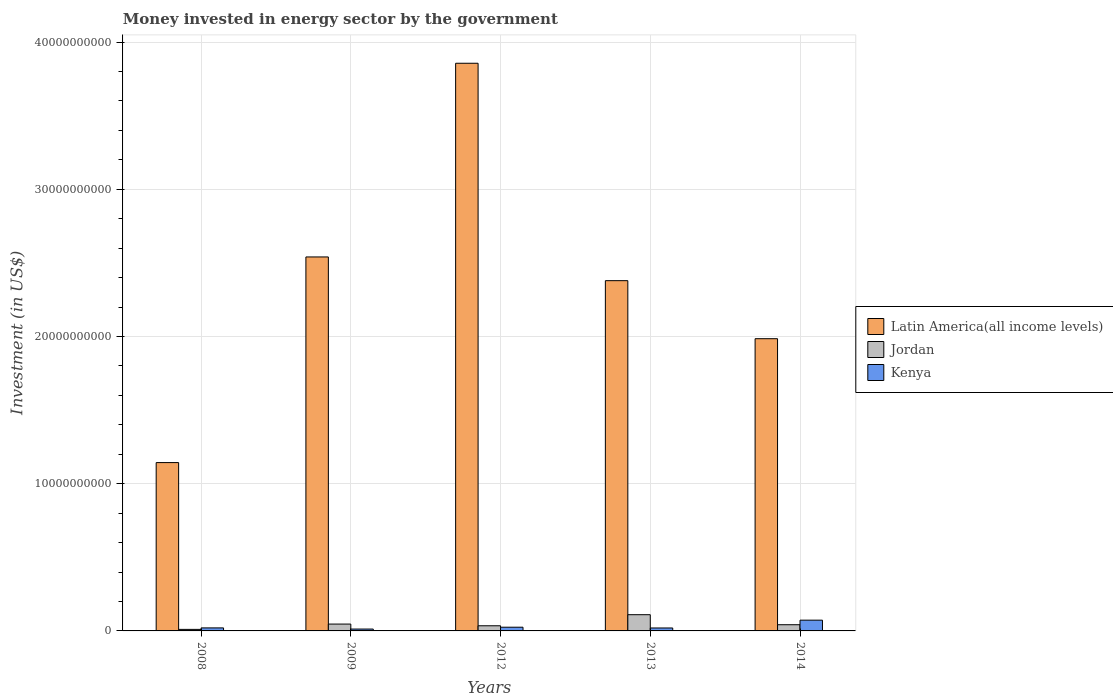Are the number of bars per tick equal to the number of legend labels?
Give a very brief answer. Yes. How many bars are there on the 2nd tick from the left?
Give a very brief answer. 3. In how many cases, is the number of bars for a given year not equal to the number of legend labels?
Provide a succinct answer. 0. What is the money spent in energy sector in Kenya in 2009?
Your answer should be very brief. 1.27e+08. Across all years, what is the maximum money spent in energy sector in Kenya?
Ensure brevity in your answer.  7.30e+08. Across all years, what is the minimum money spent in energy sector in Kenya?
Your response must be concise. 1.27e+08. In which year was the money spent in energy sector in Latin America(all income levels) minimum?
Your answer should be compact. 2008. What is the total money spent in energy sector in Jordan in the graph?
Ensure brevity in your answer.  2.44e+09. What is the difference between the money spent in energy sector in Kenya in 2009 and that in 2014?
Give a very brief answer. -6.04e+08. What is the difference between the money spent in energy sector in Kenya in 2008 and the money spent in energy sector in Jordan in 2009?
Your answer should be very brief. -2.60e+08. What is the average money spent in energy sector in Jordan per year?
Ensure brevity in your answer.  4.88e+08. In the year 2009, what is the difference between the money spent in energy sector in Latin America(all income levels) and money spent in energy sector in Jordan?
Offer a terse response. 2.49e+1. What is the ratio of the money spent in energy sector in Jordan in 2012 to that in 2014?
Give a very brief answer. 0.83. Is the difference between the money spent in energy sector in Latin America(all income levels) in 2012 and 2014 greater than the difference between the money spent in energy sector in Jordan in 2012 and 2014?
Your answer should be compact. Yes. What is the difference between the highest and the second highest money spent in energy sector in Latin America(all income levels)?
Provide a short and direct response. 1.32e+1. What is the difference between the highest and the lowest money spent in energy sector in Latin America(all income levels)?
Provide a short and direct response. 2.71e+1. Is the sum of the money spent in energy sector in Kenya in 2009 and 2012 greater than the maximum money spent in energy sector in Latin America(all income levels) across all years?
Ensure brevity in your answer.  No. What does the 2nd bar from the left in 2013 represents?
Your answer should be very brief. Jordan. What does the 3rd bar from the right in 2009 represents?
Make the answer very short. Latin America(all income levels). Are all the bars in the graph horizontal?
Give a very brief answer. No. How many years are there in the graph?
Ensure brevity in your answer.  5. What is the title of the graph?
Ensure brevity in your answer.  Money invested in energy sector by the government. What is the label or title of the X-axis?
Give a very brief answer. Years. What is the label or title of the Y-axis?
Your answer should be compact. Investment (in US$). What is the Investment (in US$) in Latin America(all income levels) in 2008?
Your answer should be very brief. 1.14e+1. What is the Investment (in US$) of Jordan in 2008?
Your response must be concise. 1.04e+08. What is the Investment (in US$) of Kenya in 2008?
Make the answer very short. 2.05e+08. What is the Investment (in US$) in Latin America(all income levels) in 2009?
Make the answer very short. 2.54e+1. What is the Investment (in US$) in Jordan in 2009?
Ensure brevity in your answer.  4.65e+08. What is the Investment (in US$) in Kenya in 2009?
Make the answer very short. 1.27e+08. What is the Investment (in US$) of Latin America(all income levels) in 2012?
Your answer should be very brief. 3.86e+1. What is the Investment (in US$) in Jordan in 2012?
Make the answer very short. 3.50e+08. What is the Investment (in US$) in Kenya in 2012?
Ensure brevity in your answer.  2.52e+08. What is the Investment (in US$) in Latin America(all income levels) in 2013?
Your response must be concise. 2.38e+1. What is the Investment (in US$) in Jordan in 2013?
Keep it short and to the point. 1.10e+09. What is the Investment (in US$) of Latin America(all income levels) in 2014?
Give a very brief answer. 1.98e+1. What is the Investment (in US$) of Jordan in 2014?
Offer a very short reply. 4.21e+08. What is the Investment (in US$) of Kenya in 2014?
Your response must be concise. 7.30e+08. Across all years, what is the maximum Investment (in US$) in Latin America(all income levels)?
Provide a short and direct response. 3.86e+1. Across all years, what is the maximum Investment (in US$) in Jordan?
Make the answer very short. 1.10e+09. Across all years, what is the maximum Investment (in US$) in Kenya?
Provide a succinct answer. 7.30e+08. Across all years, what is the minimum Investment (in US$) in Latin America(all income levels)?
Provide a succinct answer. 1.14e+1. Across all years, what is the minimum Investment (in US$) of Jordan?
Your answer should be very brief. 1.04e+08. Across all years, what is the minimum Investment (in US$) of Kenya?
Ensure brevity in your answer.  1.27e+08. What is the total Investment (in US$) in Latin America(all income levels) in the graph?
Provide a short and direct response. 1.19e+11. What is the total Investment (in US$) in Jordan in the graph?
Your answer should be compact. 2.44e+09. What is the total Investment (in US$) in Kenya in the graph?
Provide a succinct answer. 1.51e+09. What is the difference between the Investment (in US$) in Latin America(all income levels) in 2008 and that in 2009?
Your answer should be very brief. -1.40e+1. What is the difference between the Investment (in US$) of Jordan in 2008 and that in 2009?
Keep it short and to the point. -3.61e+08. What is the difference between the Investment (in US$) in Kenya in 2008 and that in 2009?
Keep it short and to the point. 7.80e+07. What is the difference between the Investment (in US$) of Latin America(all income levels) in 2008 and that in 2012?
Give a very brief answer. -2.71e+1. What is the difference between the Investment (in US$) in Jordan in 2008 and that in 2012?
Provide a short and direct response. -2.46e+08. What is the difference between the Investment (in US$) of Kenya in 2008 and that in 2012?
Ensure brevity in your answer.  -4.70e+07. What is the difference between the Investment (in US$) of Latin America(all income levels) in 2008 and that in 2013?
Keep it short and to the point. -1.24e+1. What is the difference between the Investment (in US$) in Jordan in 2008 and that in 2013?
Provide a short and direct response. -9.98e+08. What is the difference between the Investment (in US$) of Latin America(all income levels) in 2008 and that in 2014?
Give a very brief answer. -8.41e+09. What is the difference between the Investment (in US$) in Jordan in 2008 and that in 2014?
Your response must be concise. -3.17e+08. What is the difference between the Investment (in US$) in Kenya in 2008 and that in 2014?
Keep it short and to the point. -5.26e+08. What is the difference between the Investment (in US$) in Latin America(all income levels) in 2009 and that in 2012?
Your answer should be compact. -1.32e+1. What is the difference between the Investment (in US$) in Jordan in 2009 and that in 2012?
Your answer should be very brief. 1.15e+08. What is the difference between the Investment (in US$) of Kenya in 2009 and that in 2012?
Your response must be concise. -1.25e+08. What is the difference between the Investment (in US$) in Latin America(all income levels) in 2009 and that in 2013?
Offer a terse response. 1.61e+09. What is the difference between the Investment (in US$) in Jordan in 2009 and that in 2013?
Keep it short and to the point. -6.37e+08. What is the difference between the Investment (in US$) of Kenya in 2009 and that in 2013?
Your answer should be compact. -7.30e+07. What is the difference between the Investment (in US$) in Latin America(all income levels) in 2009 and that in 2014?
Offer a very short reply. 5.55e+09. What is the difference between the Investment (in US$) of Jordan in 2009 and that in 2014?
Provide a succinct answer. 4.38e+07. What is the difference between the Investment (in US$) of Kenya in 2009 and that in 2014?
Give a very brief answer. -6.04e+08. What is the difference between the Investment (in US$) in Latin America(all income levels) in 2012 and that in 2013?
Offer a terse response. 1.48e+1. What is the difference between the Investment (in US$) of Jordan in 2012 and that in 2013?
Your answer should be compact. -7.52e+08. What is the difference between the Investment (in US$) in Kenya in 2012 and that in 2013?
Your answer should be compact. 5.20e+07. What is the difference between the Investment (in US$) in Latin America(all income levels) in 2012 and that in 2014?
Your answer should be very brief. 1.87e+1. What is the difference between the Investment (in US$) of Jordan in 2012 and that in 2014?
Make the answer very short. -7.12e+07. What is the difference between the Investment (in US$) of Kenya in 2012 and that in 2014?
Provide a short and direct response. -4.78e+08. What is the difference between the Investment (in US$) in Latin America(all income levels) in 2013 and that in 2014?
Keep it short and to the point. 3.94e+09. What is the difference between the Investment (in US$) in Jordan in 2013 and that in 2014?
Your answer should be compact. 6.81e+08. What is the difference between the Investment (in US$) of Kenya in 2013 and that in 2014?
Give a very brief answer. -5.30e+08. What is the difference between the Investment (in US$) of Latin America(all income levels) in 2008 and the Investment (in US$) of Jordan in 2009?
Your answer should be very brief. 1.10e+1. What is the difference between the Investment (in US$) in Latin America(all income levels) in 2008 and the Investment (in US$) in Kenya in 2009?
Provide a short and direct response. 1.13e+1. What is the difference between the Investment (in US$) of Jordan in 2008 and the Investment (in US$) of Kenya in 2009?
Ensure brevity in your answer.  -2.30e+07. What is the difference between the Investment (in US$) in Latin America(all income levels) in 2008 and the Investment (in US$) in Jordan in 2012?
Provide a short and direct response. 1.11e+1. What is the difference between the Investment (in US$) of Latin America(all income levels) in 2008 and the Investment (in US$) of Kenya in 2012?
Ensure brevity in your answer.  1.12e+1. What is the difference between the Investment (in US$) in Jordan in 2008 and the Investment (in US$) in Kenya in 2012?
Make the answer very short. -1.48e+08. What is the difference between the Investment (in US$) in Latin America(all income levels) in 2008 and the Investment (in US$) in Jordan in 2013?
Your answer should be compact. 1.03e+1. What is the difference between the Investment (in US$) of Latin America(all income levels) in 2008 and the Investment (in US$) of Kenya in 2013?
Offer a very short reply. 1.12e+1. What is the difference between the Investment (in US$) of Jordan in 2008 and the Investment (in US$) of Kenya in 2013?
Make the answer very short. -9.60e+07. What is the difference between the Investment (in US$) of Latin America(all income levels) in 2008 and the Investment (in US$) of Jordan in 2014?
Offer a very short reply. 1.10e+1. What is the difference between the Investment (in US$) of Latin America(all income levels) in 2008 and the Investment (in US$) of Kenya in 2014?
Ensure brevity in your answer.  1.07e+1. What is the difference between the Investment (in US$) in Jordan in 2008 and the Investment (in US$) in Kenya in 2014?
Provide a succinct answer. -6.26e+08. What is the difference between the Investment (in US$) of Latin America(all income levels) in 2009 and the Investment (in US$) of Jordan in 2012?
Ensure brevity in your answer.  2.51e+1. What is the difference between the Investment (in US$) of Latin America(all income levels) in 2009 and the Investment (in US$) of Kenya in 2012?
Provide a short and direct response. 2.51e+1. What is the difference between the Investment (in US$) in Jordan in 2009 and the Investment (in US$) in Kenya in 2012?
Offer a terse response. 2.13e+08. What is the difference between the Investment (in US$) of Latin America(all income levels) in 2009 and the Investment (in US$) of Jordan in 2013?
Provide a succinct answer. 2.43e+1. What is the difference between the Investment (in US$) of Latin America(all income levels) in 2009 and the Investment (in US$) of Kenya in 2013?
Your answer should be very brief. 2.52e+1. What is the difference between the Investment (in US$) in Jordan in 2009 and the Investment (in US$) in Kenya in 2013?
Make the answer very short. 2.65e+08. What is the difference between the Investment (in US$) of Latin America(all income levels) in 2009 and the Investment (in US$) of Jordan in 2014?
Your answer should be compact. 2.50e+1. What is the difference between the Investment (in US$) of Latin America(all income levels) in 2009 and the Investment (in US$) of Kenya in 2014?
Your answer should be very brief. 2.47e+1. What is the difference between the Investment (in US$) in Jordan in 2009 and the Investment (in US$) in Kenya in 2014?
Provide a succinct answer. -2.66e+08. What is the difference between the Investment (in US$) of Latin America(all income levels) in 2012 and the Investment (in US$) of Jordan in 2013?
Provide a succinct answer. 3.75e+1. What is the difference between the Investment (in US$) of Latin America(all income levels) in 2012 and the Investment (in US$) of Kenya in 2013?
Make the answer very short. 3.84e+1. What is the difference between the Investment (in US$) of Jordan in 2012 and the Investment (in US$) of Kenya in 2013?
Your answer should be compact. 1.50e+08. What is the difference between the Investment (in US$) of Latin America(all income levels) in 2012 and the Investment (in US$) of Jordan in 2014?
Your response must be concise. 3.81e+1. What is the difference between the Investment (in US$) in Latin America(all income levels) in 2012 and the Investment (in US$) in Kenya in 2014?
Your answer should be compact. 3.78e+1. What is the difference between the Investment (in US$) of Jordan in 2012 and the Investment (in US$) of Kenya in 2014?
Provide a short and direct response. -3.80e+08. What is the difference between the Investment (in US$) of Latin America(all income levels) in 2013 and the Investment (in US$) of Jordan in 2014?
Ensure brevity in your answer.  2.34e+1. What is the difference between the Investment (in US$) in Latin America(all income levels) in 2013 and the Investment (in US$) in Kenya in 2014?
Offer a very short reply. 2.31e+1. What is the difference between the Investment (in US$) of Jordan in 2013 and the Investment (in US$) of Kenya in 2014?
Offer a terse response. 3.72e+08. What is the average Investment (in US$) in Latin America(all income levels) per year?
Provide a succinct answer. 2.38e+1. What is the average Investment (in US$) of Jordan per year?
Keep it short and to the point. 4.88e+08. What is the average Investment (in US$) in Kenya per year?
Make the answer very short. 3.03e+08. In the year 2008, what is the difference between the Investment (in US$) in Latin America(all income levels) and Investment (in US$) in Jordan?
Your answer should be very brief. 1.13e+1. In the year 2008, what is the difference between the Investment (in US$) in Latin America(all income levels) and Investment (in US$) in Kenya?
Offer a very short reply. 1.12e+1. In the year 2008, what is the difference between the Investment (in US$) of Jordan and Investment (in US$) of Kenya?
Offer a terse response. -1.01e+08. In the year 2009, what is the difference between the Investment (in US$) of Latin America(all income levels) and Investment (in US$) of Jordan?
Make the answer very short. 2.49e+1. In the year 2009, what is the difference between the Investment (in US$) in Latin America(all income levels) and Investment (in US$) in Kenya?
Offer a very short reply. 2.53e+1. In the year 2009, what is the difference between the Investment (in US$) of Jordan and Investment (in US$) of Kenya?
Your answer should be compact. 3.38e+08. In the year 2012, what is the difference between the Investment (in US$) in Latin America(all income levels) and Investment (in US$) in Jordan?
Give a very brief answer. 3.82e+1. In the year 2012, what is the difference between the Investment (in US$) in Latin America(all income levels) and Investment (in US$) in Kenya?
Your answer should be compact. 3.83e+1. In the year 2012, what is the difference between the Investment (in US$) of Jordan and Investment (in US$) of Kenya?
Offer a terse response. 9.80e+07. In the year 2013, what is the difference between the Investment (in US$) of Latin America(all income levels) and Investment (in US$) of Jordan?
Offer a terse response. 2.27e+1. In the year 2013, what is the difference between the Investment (in US$) of Latin America(all income levels) and Investment (in US$) of Kenya?
Your answer should be compact. 2.36e+1. In the year 2013, what is the difference between the Investment (in US$) of Jordan and Investment (in US$) of Kenya?
Ensure brevity in your answer.  9.02e+08. In the year 2014, what is the difference between the Investment (in US$) of Latin America(all income levels) and Investment (in US$) of Jordan?
Provide a succinct answer. 1.94e+1. In the year 2014, what is the difference between the Investment (in US$) in Latin America(all income levels) and Investment (in US$) in Kenya?
Ensure brevity in your answer.  1.91e+1. In the year 2014, what is the difference between the Investment (in US$) of Jordan and Investment (in US$) of Kenya?
Give a very brief answer. -3.09e+08. What is the ratio of the Investment (in US$) in Latin America(all income levels) in 2008 to that in 2009?
Provide a succinct answer. 0.45. What is the ratio of the Investment (in US$) in Jordan in 2008 to that in 2009?
Make the answer very short. 0.22. What is the ratio of the Investment (in US$) in Kenya in 2008 to that in 2009?
Make the answer very short. 1.61. What is the ratio of the Investment (in US$) in Latin America(all income levels) in 2008 to that in 2012?
Your response must be concise. 0.3. What is the ratio of the Investment (in US$) of Jordan in 2008 to that in 2012?
Provide a succinct answer. 0.3. What is the ratio of the Investment (in US$) in Kenya in 2008 to that in 2012?
Ensure brevity in your answer.  0.81. What is the ratio of the Investment (in US$) of Latin America(all income levels) in 2008 to that in 2013?
Offer a terse response. 0.48. What is the ratio of the Investment (in US$) of Jordan in 2008 to that in 2013?
Provide a succinct answer. 0.09. What is the ratio of the Investment (in US$) in Latin America(all income levels) in 2008 to that in 2014?
Give a very brief answer. 0.58. What is the ratio of the Investment (in US$) in Jordan in 2008 to that in 2014?
Your response must be concise. 0.25. What is the ratio of the Investment (in US$) of Kenya in 2008 to that in 2014?
Your answer should be compact. 0.28. What is the ratio of the Investment (in US$) of Latin America(all income levels) in 2009 to that in 2012?
Your answer should be compact. 0.66. What is the ratio of the Investment (in US$) in Jordan in 2009 to that in 2012?
Your answer should be compact. 1.33. What is the ratio of the Investment (in US$) of Kenya in 2009 to that in 2012?
Your answer should be compact. 0.5. What is the ratio of the Investment (in US$) in Latin America(all income levels) in 2009 to that in 2013?
Provide a succinct answer. 1.07. What is the ratio of the Investment (in US$) of Jordan in 2009 to that in 2013?
Provide a short and direct response. 0.42. What is the ratio of the Investment (in US$) of Kenya in 2009 to that in 2013?
Your answer should be very brief. 0.64. What is the ratio of the Investment (in US$) of Latin America(all income levels) in 2009 to that in 2014?
Keep it short and to the point. 1.28. What is the ratio of the Investment (in US$) in Jordan in 2009 to that in 2014?
Offer a terse response. 1.1. What is the ratio of the Investment (in US$) in Kenya in 2009 to that in 2014?
Offer a terse response. 0.17. What is the ratio of the Investment (in US$) of Latin America(all income levels) in 2012 to that in 2013?
Give a very brief answer. 1.62. What is the ratio of the Investment (in US$) of Jordan in 2012 to that in 2013?
Your answer should be compact. 0.32. What is the ratio of the Investment (in US$) in Kenya in 2012 to that in 2013?
Give a very brief answer. 1.26. What is the ratio of the Investment (in US$) in Latin America(all income levels) in 2012 to that in 2014?
Offer a very short reply. 1.94. What is the ratio of the Investment (in US$) of Jordan in 2012 to that in 2014?
Offer a terse response. 0.83. What is the ratio of the Investment (in US$) of Kenya in 2012 to that in 2014?
Your answer should be very brief. 0.34. What is the ratio of the Investment (in US$) of Latin America(all income levels) in 2013 to that in 2014?
Your answer should be very brief. 1.2. What is the ratio of the Investment (in US$) of Jordan in 2013 to that in 2014?
Your answer should be compact. 2.62. What is the ratio of the Investment (in US$) of Kenya in 2013 to that in 2014?
Keep it short and to the point. 0.27. What is the difference between the highest and the second highest Investment (in US$) in Latin America(all income levels)?
Make the answer very short. 1.32e+1. What is the difference between the highest and the second highest Investment (in US$) of Jordan?
Keep it short and to the point. 6.37e+08. What is the difference between the highest and the second highest Investment (in US$) in Kenya?
Offer a terse response. 4.78e+08. What is the difference between the highest and the lowest Investment (in US$) of Latin America(all income levels)?
Give a very brief answer. 2.71e+1. What is the difference between the highest and the lowest Investment (in US$) in Jordan?
Keep it short and to the point. 9.98e+08. What is the difference between the highest and the lowest Investment (in US$) in Kenya?
Your response must be concise. 6.04e+08. 